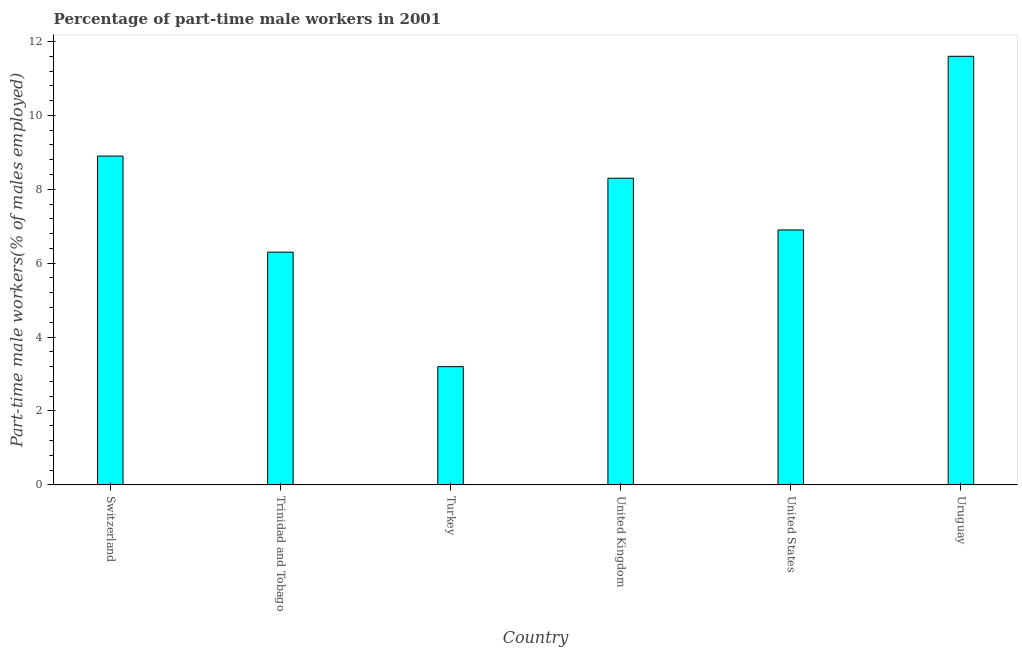Does the graph contain any zero values?
Offer a very short reply. No. What is the title of the graph?
Give a very brief answer. Percentage of part-time male workers in 2001. What is the label or title of the X-axis?
Offer a very short reply. Country. What is the label or title of the Y-axis?
Your answer should be very brief. Part-time male workers(% of males employed). What is the percentage of part-time male workers in Trinidad and Tobago?
Provide a succinct answer. 6.3. Across all countries, what is the maximum percentage of part-time male workers?
Offer a very short reply. 11.6. Across all countries, what is the minimum percentage of part-time male workers?
Your response must be concise. 3.2. In which country was the percentage of part-time male workers maximum?
Provide a short and direct response. Uruguay. In which country was the percentage of part-time male workers minimum?
Keep it short and to the point. Turkey. What is the sum of the percentage of part-time male workers?
Keep it short and to the point. 45.2. What is the average percentage of part-time male workers per country?
Give a very brief answer. 7.53. What is the median percentage of part-time male workers?
Provide a succinct answer. 7.6. In how many countries, is the percentage of part-time male workers greater than 11.6 %?
Your answer should be compact. 1. What is the ratio of the percentage of part-time male workers in Trinidad and Tobago to that in Uruguay?
Your answer should be compact. 0.54. Is the percentage of part-time male workers in Trinidad and Tobago less than that in United Kingdom?
Provide a short and direct response. Yes. Is the sum of the percentage of part-time male workers in Turkey and United Kingdom greater than the maximum percentage of part-time male workers across all countries?
Your answer should be very brief. No. Are all the bars in the graph horizontal?
Your answer should be very brief. No. How many countries are there in the graph?
Offer a very short reply. 6. What is the Part-time male workers(% of males employed) in Switzerland?
Give a very brief answer. 8.9. What is the Part-time male workers(% of males employed) of Trinidad and Tobago?
Your answer should be very brief. 6.3. What is the Part-time male workers(% of males employed) in Turkey?
Give a very brief answer. 3.2. What is the Part-time male workers(% of males employed) of United Kingdom?
Your response must be concise. 8.3. What is the Part-time male workers(% of males employed) in United States?
Your answer should be very brief. 6.9. What is the Part-time male workers(% of males employed) of Uruguay?
Your answer should be very brief. 11.6. What is the difference between the Part-time male workers(% of males employed) in Switzerland and Trinidad and Tobago?
Give a very brief answer. 2.6. What is the difference between the Part-time male workers(% of males employed) in Switzerland and Turkey?
Your response must be concise. 5.7. What is the difference between the Part-time male workers(% of males employed) in Switzerland and Uruguay?
Offer a terse response. -2.7. What is the difference between the Part-time male workers(% of males employed) in Trinidad and Tobago and Uruguay?
Provide a succinct answer. -5.3. What is the difference between the Part-time male workers(% of males employed) in Turkey and United States?
Your response must be concise. -3.7. What is the difference between the Part-time male workers(% of males employed) in United States and Uruguay?
Your response must be concise. -4.7. What is the ratio of the Part-time male workers(% of males employed) in Switzerland to that in Trinidad and Tobago?
Provide a succinct answer. 1.41. What is the ratio of the Part-time male workers(% of males employed) in Switzerland to that in Turkey?
Your answer should be very brief. 2.78. What is the ratio of the Part-time male workers(% of males employed) in Switzerland to that in United Kingdom?
Make the answer very short. 1.07. What is the ratio of the Part-time male workers(% of males employed) in Switzerland to that in United States?
Offer a very short reply. 1.29. What is the ratio of the Part-time male workers(% of males employed) in Switzerland to that in Uruguay?
Your answer should be very brief. 0.77. What is the ratio of the Part-time male workers(% of males employed) in Trinidad and Tobago to that in Turkey?
Keep it short and to the point. 1.97. What is the ratio of the Part-time male workers(% of males employed) in Trinidad and Tobago to that in United Kingdom?
Provide a short and direct response. 0.76. What is the ratio of the Part-time male workers(% of males employed) in Trinidad and Tobago to that in United States?
Offer a very short reply. 0.91. What is the ratio of the Part-time male workers(% of males employed) in Trinidad and Tobago to that in Uruguay?
Make the answer very short. 0.54. What is the ratio of the Part-time male workers(% of males employed) in Turkey to that in United Kingdom?
Your answer should be compact. 0.39. What is the ratio of the Part-time male workers(% of males employed) in Turkey to that in United States?
Your answer should be very brief. 0.46. What is the ratio of the Part-time male workers(% of males employed) in Turkey to that in Uruguay?
Your answer should be compact. 0.28. What is the ratio of the Part-time male workers(% of males employed) in United Kingdom to that in United States?
Your answer should be very brief. 1.2. What is the ratio of the Part-time male workers(% of males employed) in United Kingdom to that in Uruguay?
Ensure brevity in your answer.  0.72. What is the ratio of the Part-time male workers(% of males employed) in United States to that in Uruguay?
Give a very brief answer. 0.59. 